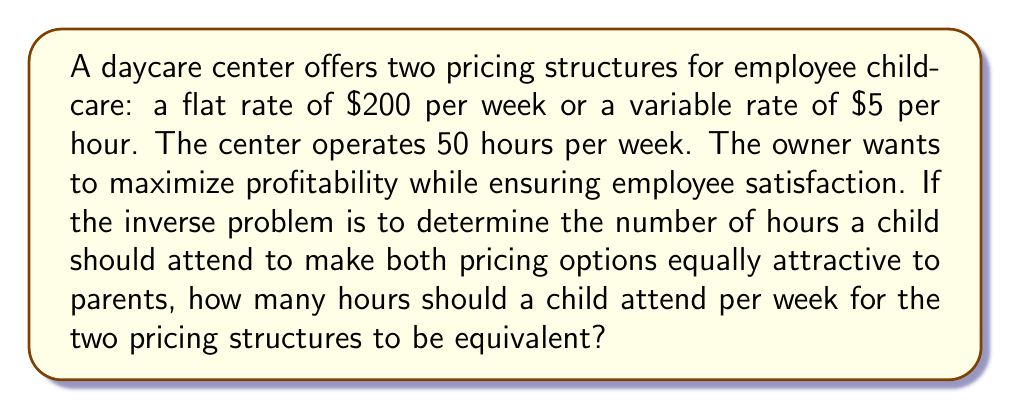Help me with this question. Let's approach this step-by-step:

1) Let $x$ be the number of hours a child attends per week.

2) For the flat rate option, the cost is always $200 per week, regardless of hours attended.

3) For the variable rate option, the cost is $5 per hour. So for $x$ hours, the cost would be $5x$.

4) To find the point where these two options are equivalent, we set up the equation:

   $$200 = 5x$$

5) Solving for $x$:
   
   $$x = \frac{200}{5} = 40$$

6) Therefore, at 40 hours per week, both pricing structures result in the same cost for parents.

7) We can verify:
   - Flat rate: $200 per week
   - Variable rate: $5 * 40 = $200 per week

8) This solution provides insight for both the daycare owner and employees:
   - For children attending more than 40 hours per week, the flat rate is more economical.
   - For children attending less than 40 hours per week, the hourly rate is more economical.

9) The daycare owner can use this information to balance profitability and employee satisfaction:
   - Employees with children needing full-time care (close to 50 hours) might prefer the flat rate.
   - Employees with children needing part-time care might prefer the hourly rate.
   - The breakeven point at 40 hours allows for a fair and flexible pricing structure.
Answer: 40 hours 